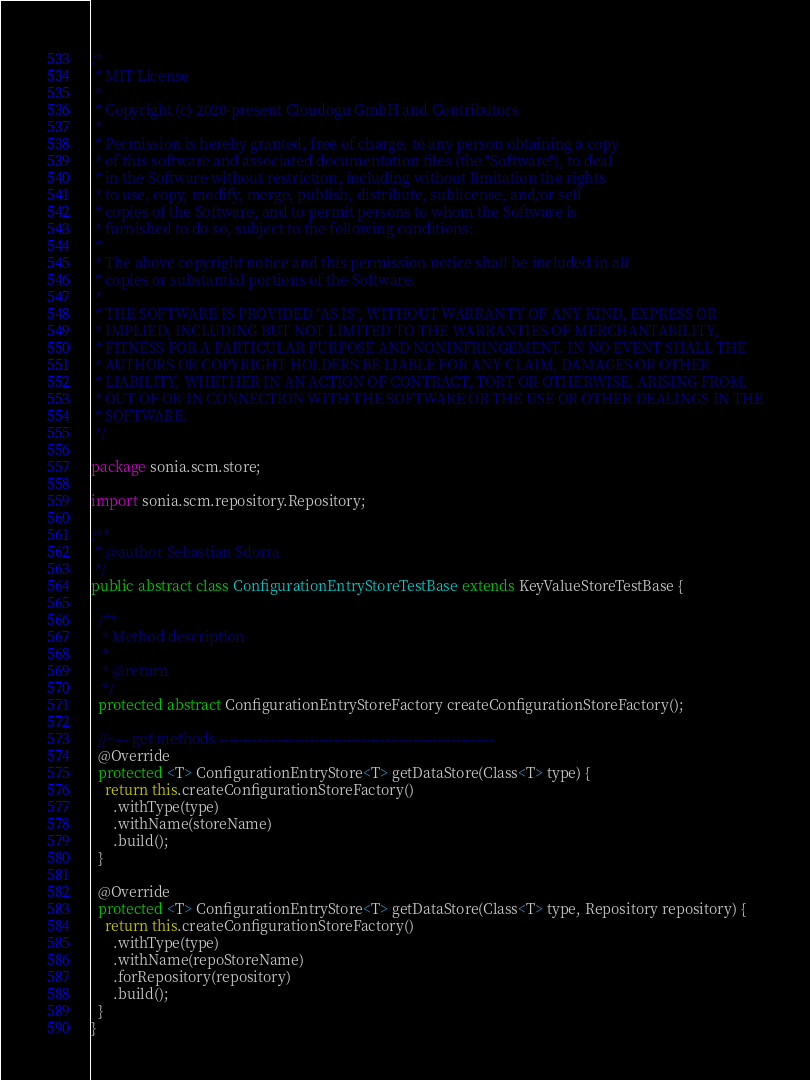Convert code to text. <code><loc_0><loc_0><loc_500><loc_500><_Java_>/*
 * MIT License
 *
 * Copyright (c) 2020-present Cloudogu GmbH and Contributors
 *
 * Permission is hereby granted, free of charge, to any person obtaining a copy
 * of this software and associated documentation files (the "Software"), to deal
 * in the Software without restriction, including without limitation the rights
 * to use, copy, modify, merge, publish, distribute, sublicense, and/or sell
 * copies of the Software, and to permit persons to whom the Software is
 * furnished to do so, subject to the following conditions:
 *
 * The above copyright notice and this permission notice shall be included in all
 * copies or substantial portions of the Software.
 *
 * THE SOFTWARE IS PROVIDED "AS IS", WITHOUT WARRANTY OF ANY KIND, EXPRESS OR
 * IMPLIED, INCLUDING BUT NOT LIMITED TO THE WARRANTIES OF MERCHANTABILITY,
 * FITNESS FOR A PARTICULAR PURPOSE AND NONINFRINGEMENT. IN NO EVENT SHALL THE
 * AUTHORS OR COPYRIGHT HOLDERS BE LIABLE FOR ANY CLAIM, DAMAGES OR OTHER
 * LIABILITY, WHETHER IN AN ACTION OF CONTRACT, TORT OR OTHERWISE, ARISING FROM,
 * OUT OF OR IN CONNECTION WITH THE SOFTWARE OR THE USE OR OTHER DEALINGS IN THE
 * SOFTWARE.
 */

package sonia.scm.store;

import sonia.scm.repository.Repository;

/**
 * @author Sebastian Sdorra
 */
public abstract class ConfigurationEntryStoreTestBase extends KeyValueStoreTestBase {

  /**
   * Method description
   *
   * @return
   */
  protected abstract ConfigurationEntryStoreFactory createConfigurationStoreFactory();

  //~--- get methods ----------------------------------------------------------
  @Override
  protected <T> ConfigurationEntryStore<T> getDataStore(Class<T> type) {
    return this.createConfigurationStoreFactory()
      .withType(type)
      .withName(storeName)
      .build();
  }

  @Override
  protected <T> ConfigurationEntryStore<T> getDataStore(Class<T> type, Repository repository) {
    return this.createConfigurationStoreFactory()
      .withType(type)
      .withName(repoStoreName)
      .forRepository(repository)
      .build();
  }
}
</code> 